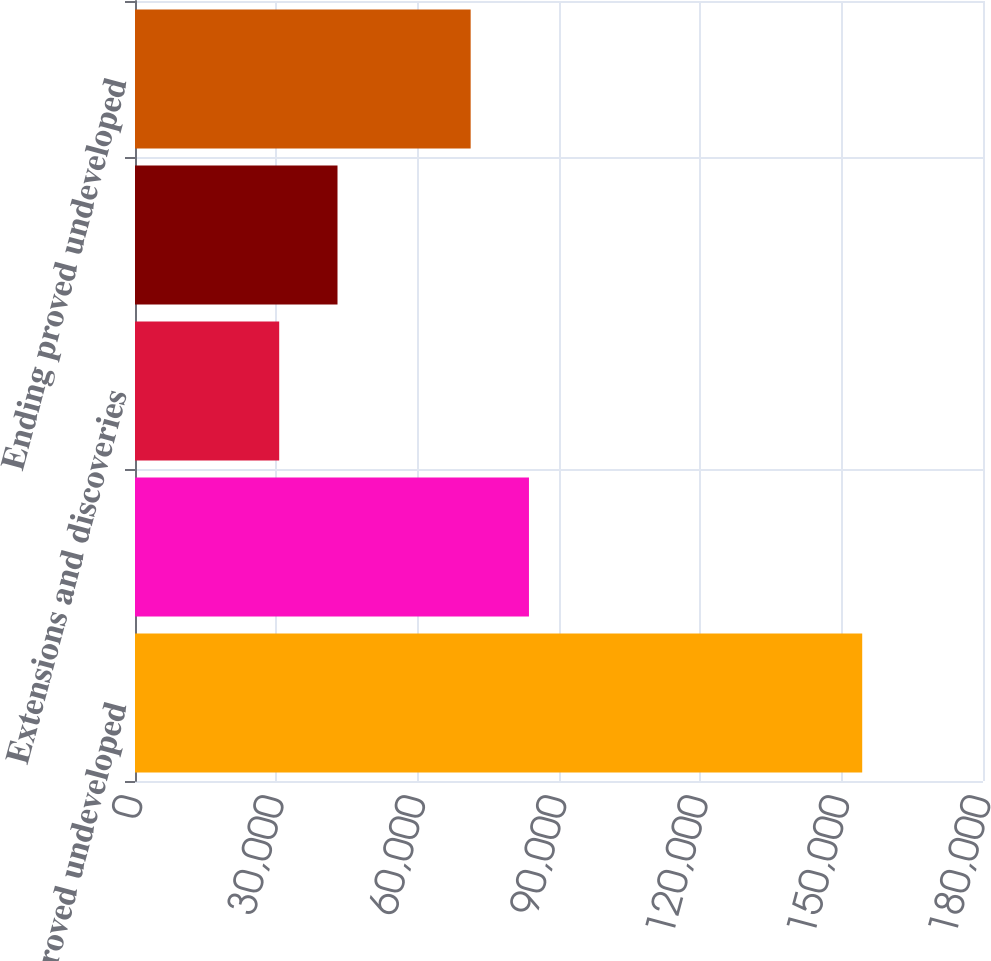<chart> <loc_0><loc_0><loc_500><loc_500><bar_chart><fcel>Beginning proved undeveloped<fcel>Revisions of previous<fcel>Extensions and discoveries<fcel>Transfers to proved developed<fcel>Ending proved undeveloped<nl><fcel>154360<fcel>83624.1<fcel>30609<fcel>42984.1<fcel>71249<nl></chart> 